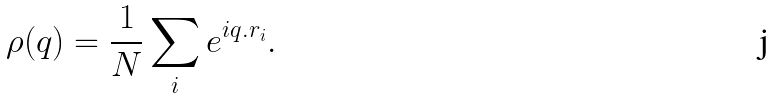Convert formula to latex. <formula><loc_0><loc_0><loc_500><loc_500>\rho ( { q } ) = \frac { 1 } { N } \sum _ { i } e ^ { i { q } . { r } _ { i } } .</formula> 